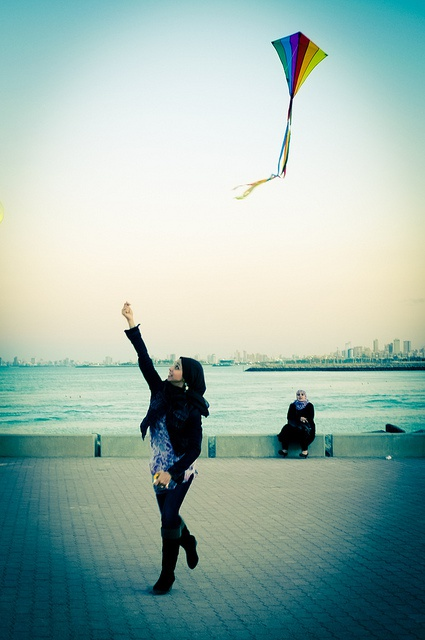Describe the objects in this image and their specific colors. I can see people in lightblue, black, darkgray, blue, and navy tones, kite in turquoise, ivory, olive, maroon, and blue tones, and people in turquoise, black, darkgray, blue, and navy tones in this image. 